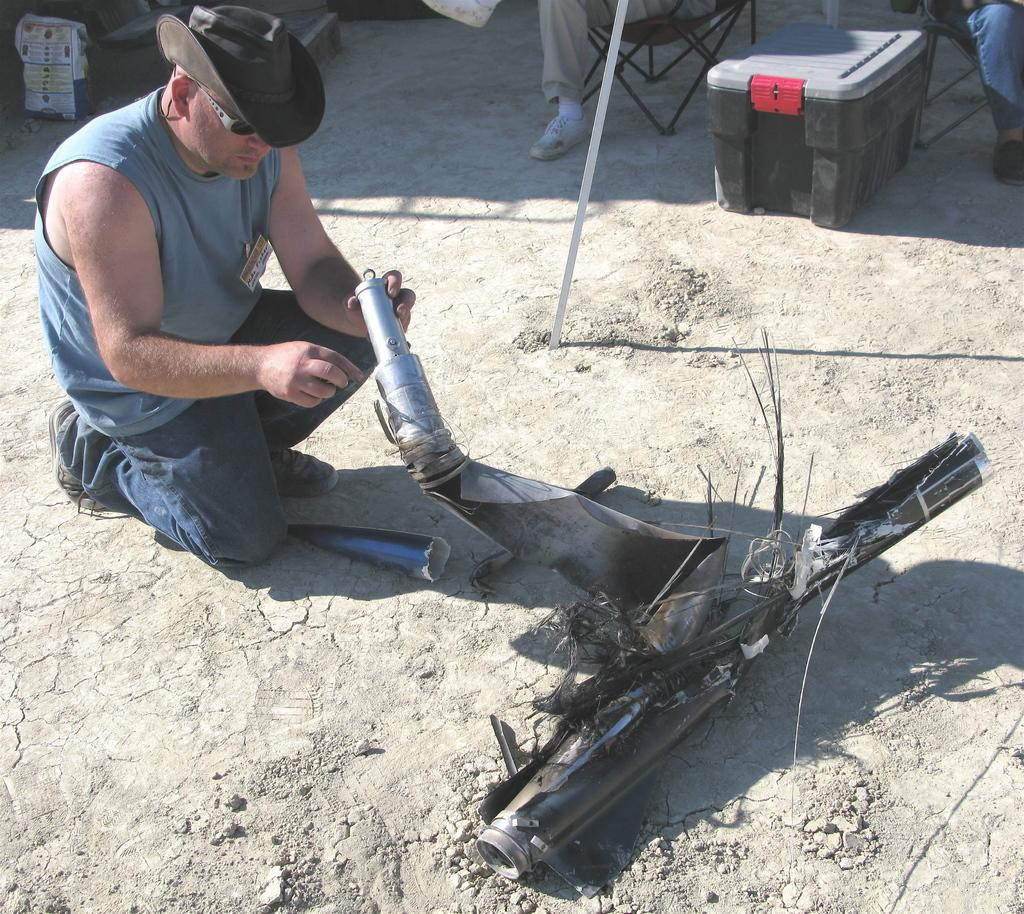What is the man in the image doing? The man is sitting on the ground in the image. What is the man holding in the image? The man is holding some objects in the image. What else can be seen near the man? There are objects beside the man in the image. Are there any other people in the image? Yes, there are people in the image. What type of fish can be seen swimming in the man's heart in the image? There is no fish or heart present in the image; it only shows a man sitting on the ground with objects. 